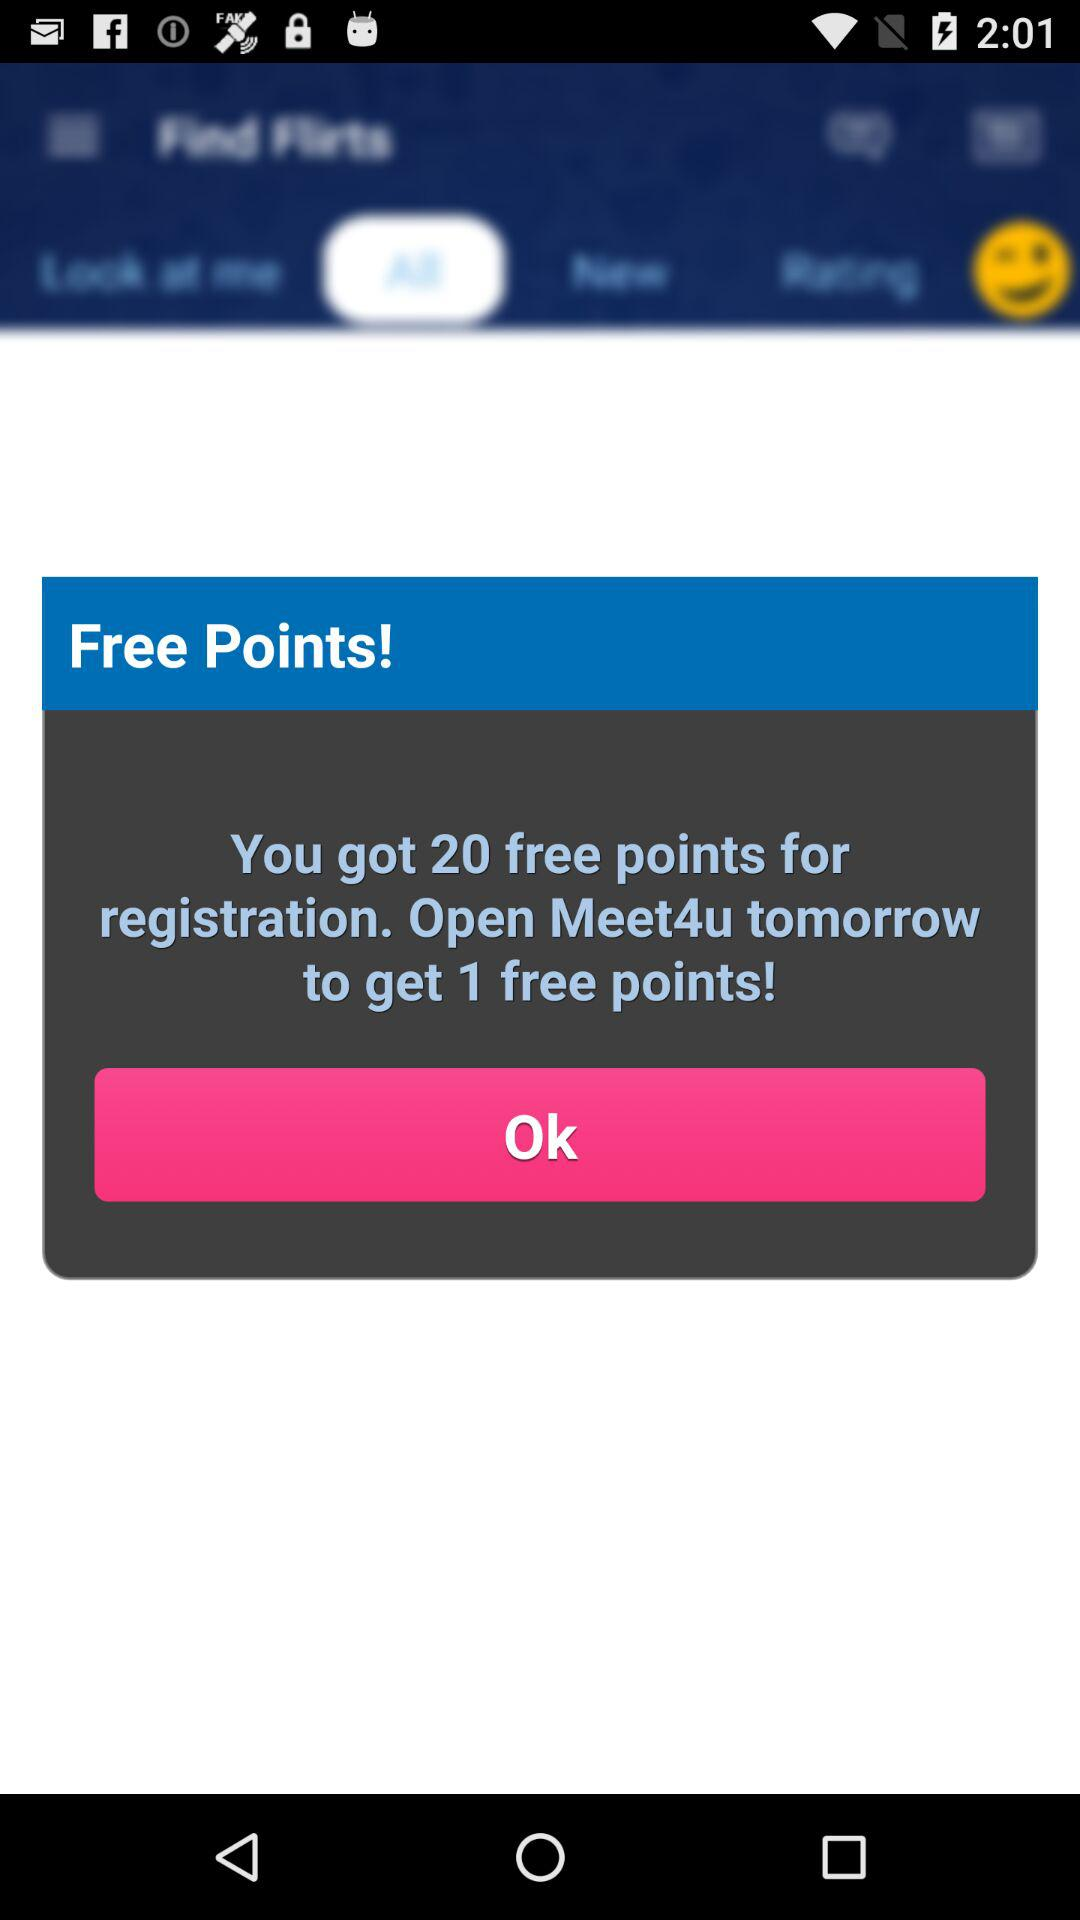What's the number of free points earned for registration? The number of free points earned for registration is 20. 